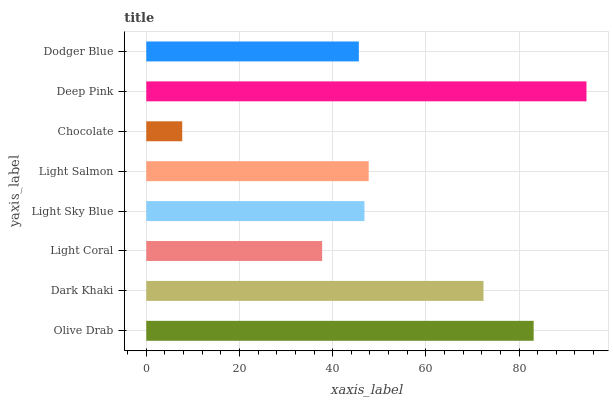Is Chocolate the minimum?
Answer yes or no. Yes. Is Deep Pink the maximum?
Answer yes or no. Yes. Is Dark Khaki the minimum?
Answer yes or no. No. Is Dark Khaki the maximum?
Answer yes or no. No. Is Olive Drab greater than Dark Khaki?
Answer yes or no. Yes. Is Dark Khaki less than Olive Drab?
Answer yes or no. Yes. Is Dark Khaki greater than Olive Drab?
Answer yes or no. No. Is Olive Drab less than Dark Khaki?
Answer yes or no. No. Is Light Salmon the high median?
Answer yes or no. Yes. Is Light Sky Blue the low median?
Answer yes or no. Yes. Is Olive Drab the high median?
Answer yes or no. No. Is Deep Pink the low median?
Answer yes or no. No. 